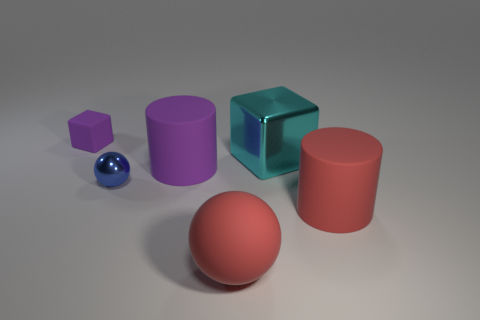The shiny object that is in front of the big cyan cube that is right of the big rubber cylinder that is behind the blue shiny sphere is what shape?
Your answer should be compact. Sphere. What is the material of the large cylinder that is behind the blue metal thing?
Offer a terse response. Rubber. There is a cube that is the same size as the blue object; what color is it?
Provide a succinct answer. Purple. Do the cyan metal object and the blue object have the same size?
Your response must be concise. No. Is the number of large cylinders that are behind the cyan object greater than the number of small matte things that are to the left of the large red sphere?
Offer a terse response. No. What number of other things are the same size as the cyan shiny thing?
Give a very brief answer. 3. Does the large cylinder behind the blue metallic sphere have the same color as the small matte object?
Offer a terse response. Yes. Are there more blocks that are behind the purple cylinder than green blocks?
Keep it short and to the point. Yes. Are there any other things that are the same color as the large block?
Offer a very short reply. No. There is a matte thing on the right side of the metallic object that is to the right of the small blue metal object; what is its shape?
Provide a succinct answer. Cylinder. 